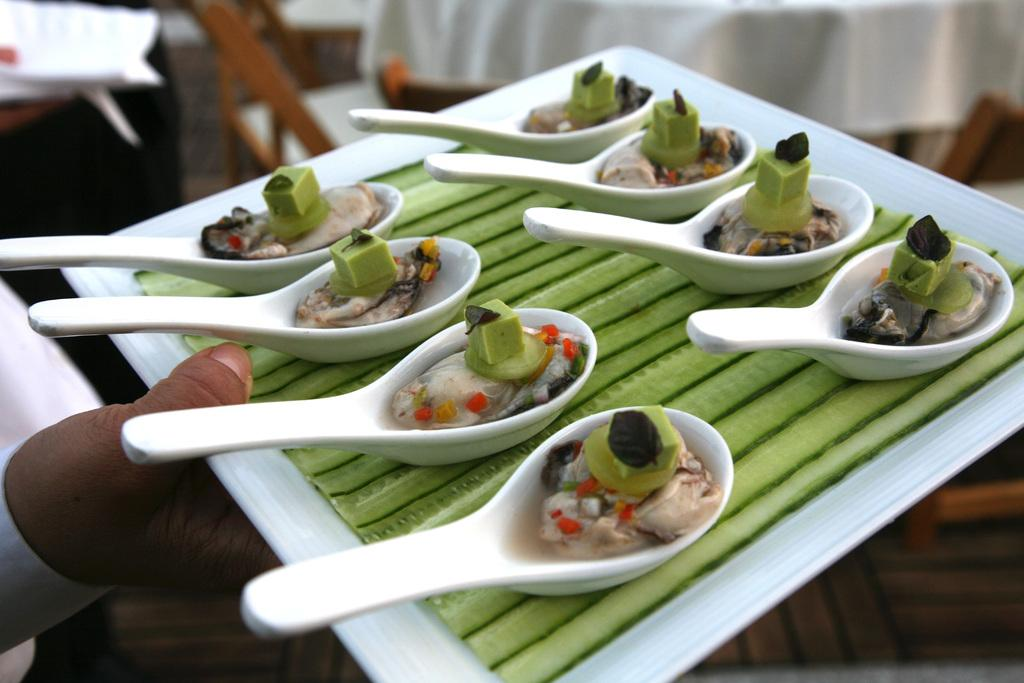What is the main subject of the image? There is a person in the image. What is the person holding in the image? The person is holding a tray. What is on the tray that the person is holding? The tray contains spoons and food. Can you describe the background of the image? The background of the image is blurry. What else can be seen in the image besides the person and the tray? There is a white cloth visible in the image. What type of pickle is being used in the game in the image? There is no pickle or game present in the image; it features a person holding a tray with spoons and food. Can you see any wounds on the person in the image? There is no indication of any wounds on the person in the image. 